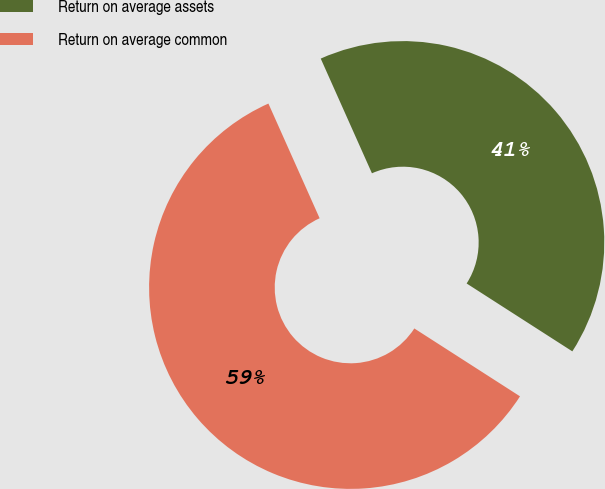Convert chart. <chart><loc_0><loc_0><loc_500><loc_500><pie_chart><fcel>Return on average assets<fcel>Return on average common<nl><fcel>40.77%<fcel>59.23%<nl></chart> 